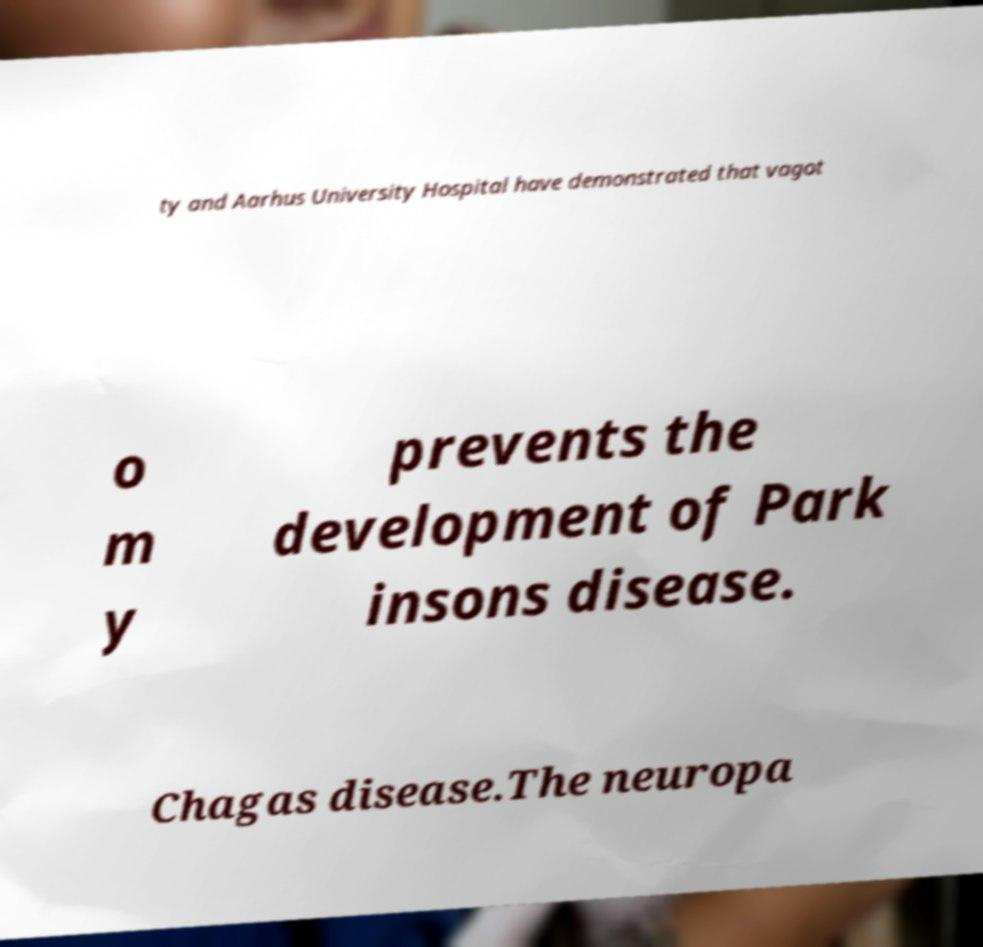For documentation purposes, I need the text within this image transcribed. Could you provide that? ty and Aarhus University Hospital have demonstrated that vagot o m y prevents the development of Park insons disease. Chagas disease.The neuropa 